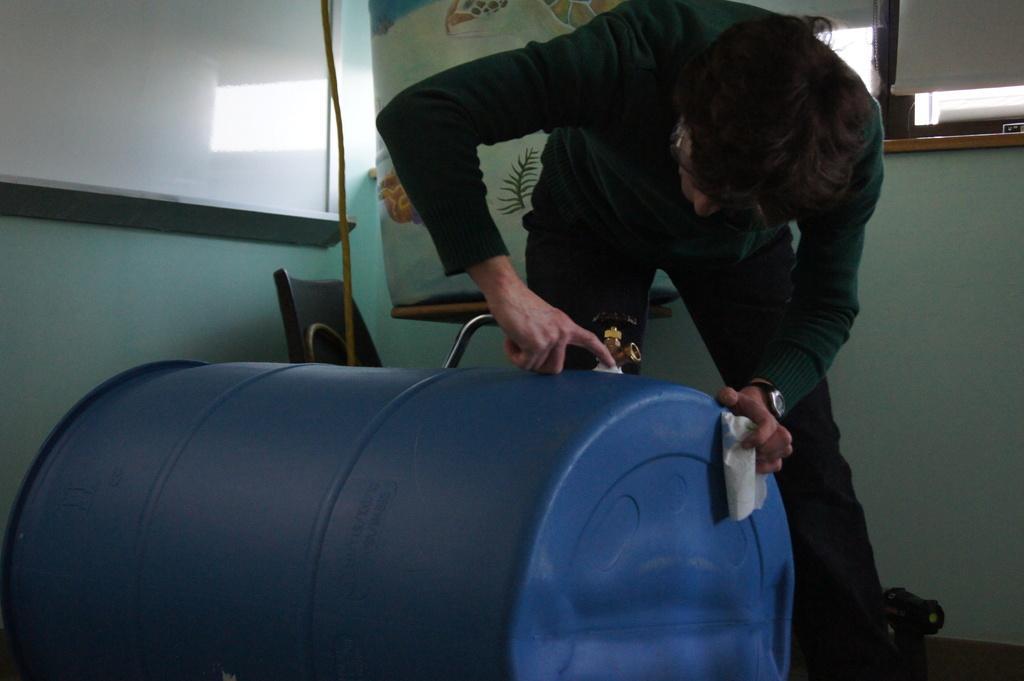Describe this image in one or two sentences. In the center of the image we can see a man repairing a drum. In the background there is a window, board, chair and a wall. 